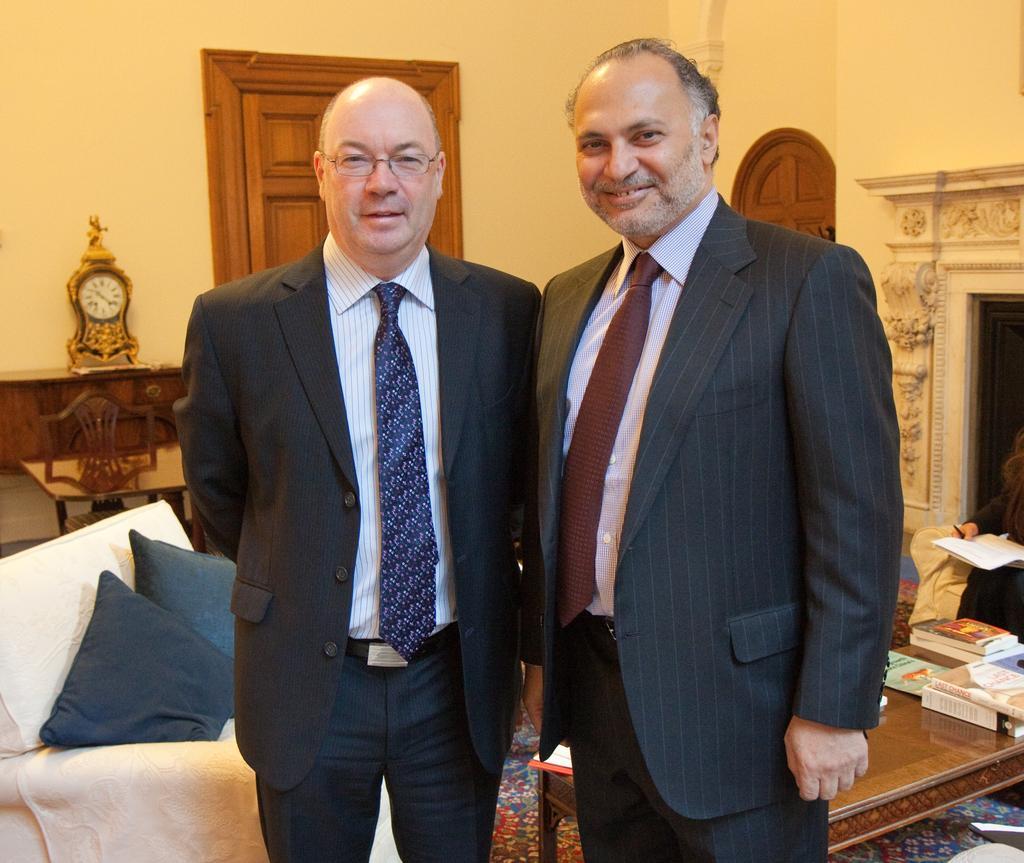Describe this image in one or two sentences. In the image we can see there are men standing and they are wearing formal suits and behind there are books kept on the table. There is a clock kept on the table near the wall. 